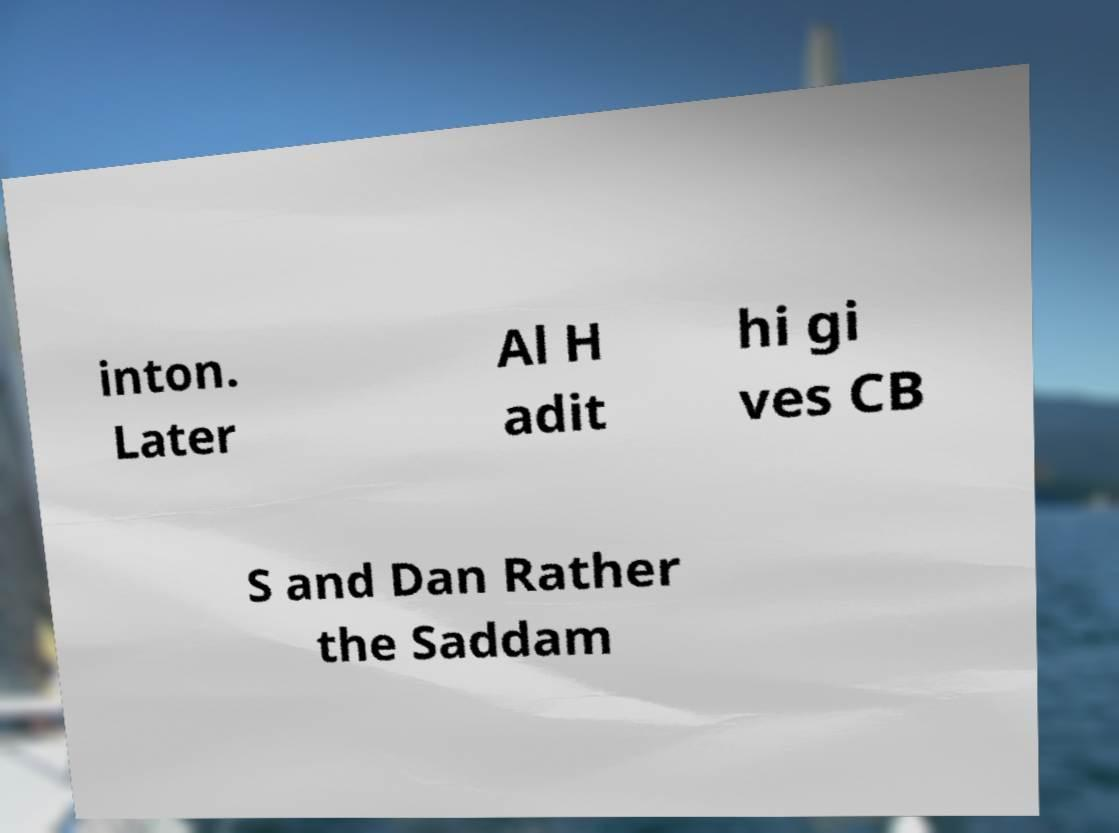Can you accurately transcribe the text from the provided image for me? inton. Later Al H adit hi gi ves CB S and Dan Rather the Saddam 